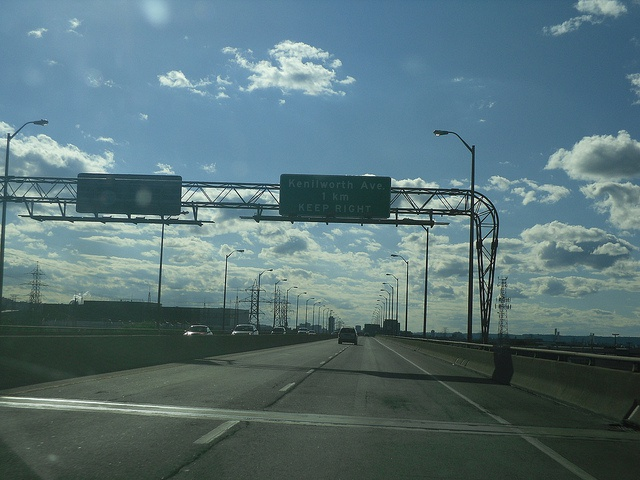Describe the objects in this image and their specific colors. I can see truck in gray and black tones, car in gray, black, teal, and darkgray tones, car in gray and black tones, car in gray and black tones, and car in gray, black, and purple tones in this image. 